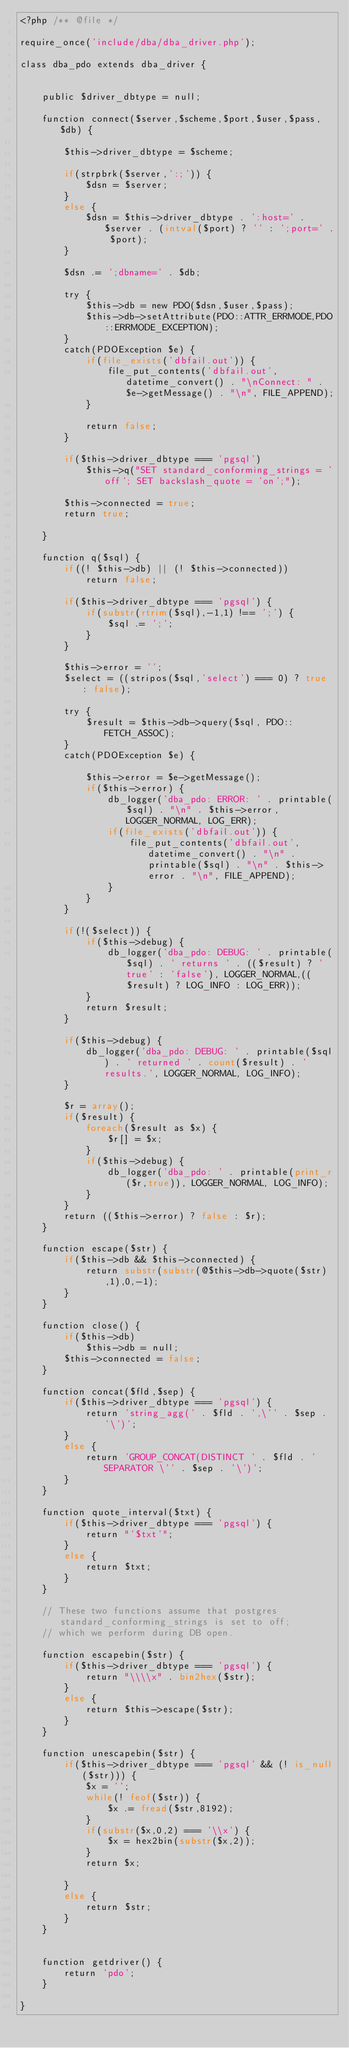<code> <loc_0><loc_0><loc_500><loc_500><_PHP_><?php /** @file */

require_once('include/dba/dba_driver.php');

class dba_pdo extends dba_driver {


	public $driver_dbtype = null;

	function connect($server,$scheme,$port,$user,$pass,$db) {
		
		$this->driver_dbtype = $scheme;

		if(strpbrk($server,':;')) {
			$dsn = $server;
		}
		else {
			$dsn = $this->driver_dbtype . ':host=' . $server . (intval($port) ? '' : ';port=' . $port);
		}
		
		$dsn .= ';dbname=' . $db;

		try {
			$this->db = new PDO($dsn,$user,$pass);
			$this->db->setAttribute(PDO::ATTR_ERRMODE,PDO::ERRMODE_EXCEPTION);
		}
		catch(PDOException $e) {
			if(file_exists('dbfail.out')) {
				file_put_contents('dbfail.out', datetime_convert() . "\nConnect: " . $e->getMessage() . "\n", FILE_APPEND);
			}

			return false;
		}

		if($this->driver_dbtype === 'pgsql')
			$this->q("SET standard_conforming_strings = 'off'; SET backslash_quote = 'on';");

		$this->connected = true;
		return true;

	}

	function q($sql) {
		if((! $this->db) || (! $this->connected))
			return false;

		if($this->driver_dbtype === 'pgsql') {
			if(substr(rtrim($sql),-1,1) !== ';') {
				$sql .= ';';
			}
		}

		$this->error = '';
		$select = ((stripos($sql,'select') === 0) ? true : false);

		try {
			$result = $this->db->query($sql, PDO::FETCH_ASSOC);
		}
		catch(PDOException $e) {
	
			$this->error = $e->getMessage();
			if($this->error) {
				db_logger('dba_pdo: ERROR: ' . printable($sql) . "\n" . $this->error, LOGGER_NORMAL, LOG_ERR);
				if(file_exists('dbfail.out')) {
					file_put_contents('dbfail.out', datetime_convert() . "\n" . printable($sql) . "\n" . $this->error . "\n", FILE_APPEND);
				}
			}
		}

		if(!($select)) {
			if($this->debug) {
				db_logger('dba_pdo: DEBUG: ' . printable($sql) . ' returns ' . (($result) ? 'true' : 'false'), LOGGER_NORMAL,(($result) ? LOG_INFO : LOG_ERR));
			}
			return $result;
		}

		if($this->debug) {
			db_logger('dba_pdo: DEBUG: ' . printable($sql) . ' returned ' . count($result) . ' results.', LOGGER_NORMAL, LOG_INFO); 
		}

		$r = array();
		if($result) {
			foreach($result as $x) {
				$r[] = $x;
			}
			if($this->debug) {
				db_logger('dba_pdo: ' . printable(print_r($r,true)), LOGGER_NORMAL, LOG_INFO);
			}
		}
		return (($this->error) ? false : $r);
	}

	function escape($str) {
		if($this->db && $this->connected) {
			return substr(substr(@$this->db->quote($str),1),0,-1);
		}
	}

	function close() {
		if($this->db)
			$this->db = null;
		$this->connected = false;
	}
	
	function concat($fld,$sep) {
		if($this->driver_dbtype === 'pgsql') {
			return 'string_agg(' . $fld . ',\'' . $sep . '\')';
		}
		else {
			return 'GROUP_CONCAT(DISTINCT ' . $fld . ' SEPARATOR \'' . $sep . '\')';
		}
	}

	function quote_interval($txt) {
		if($this->driver_dbtype === 'pgsql') {
			return "'$txt'";
		}
		else {
			return $txt;
		}
	}

	// These two functions assume that postgres standard_conforming_strings is set to off;
	// which we perform during DB open.

	function escapebin($str) {
		if($this->driver_dbtype === 'pgsql') {
			return "\\\\x" . bin2hex($str);
		}
		else {
			return $this->escape($str);
		}
	}
	
	function unescapebin($str) {
		if($this->driver_dbtype === 'pgsql' && (! is_null($str))) {
			$x = '';
			while(! feof($str)) {
				$x .= fread($str,8192);
			}
			if(substr($x,0,2) === '\\x') {
				$x = hex2bin(substr($x,2));
			}
			return $x;

		}
		else {
			return $str;
		}
	}


	function getdriver() {
		return 'pdo';
	}

}</code> 